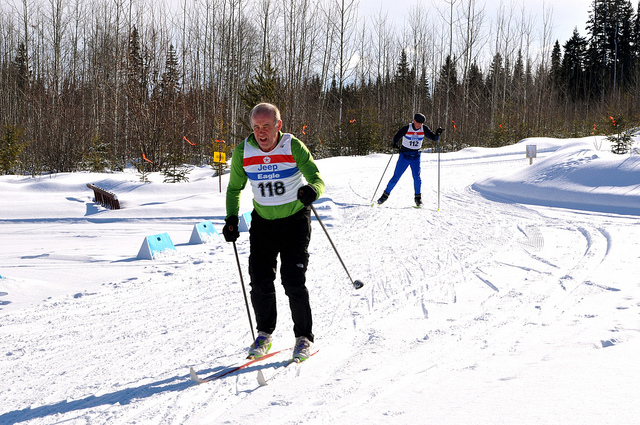Identify the text contained in this image. Jeep Baglo 118 112 